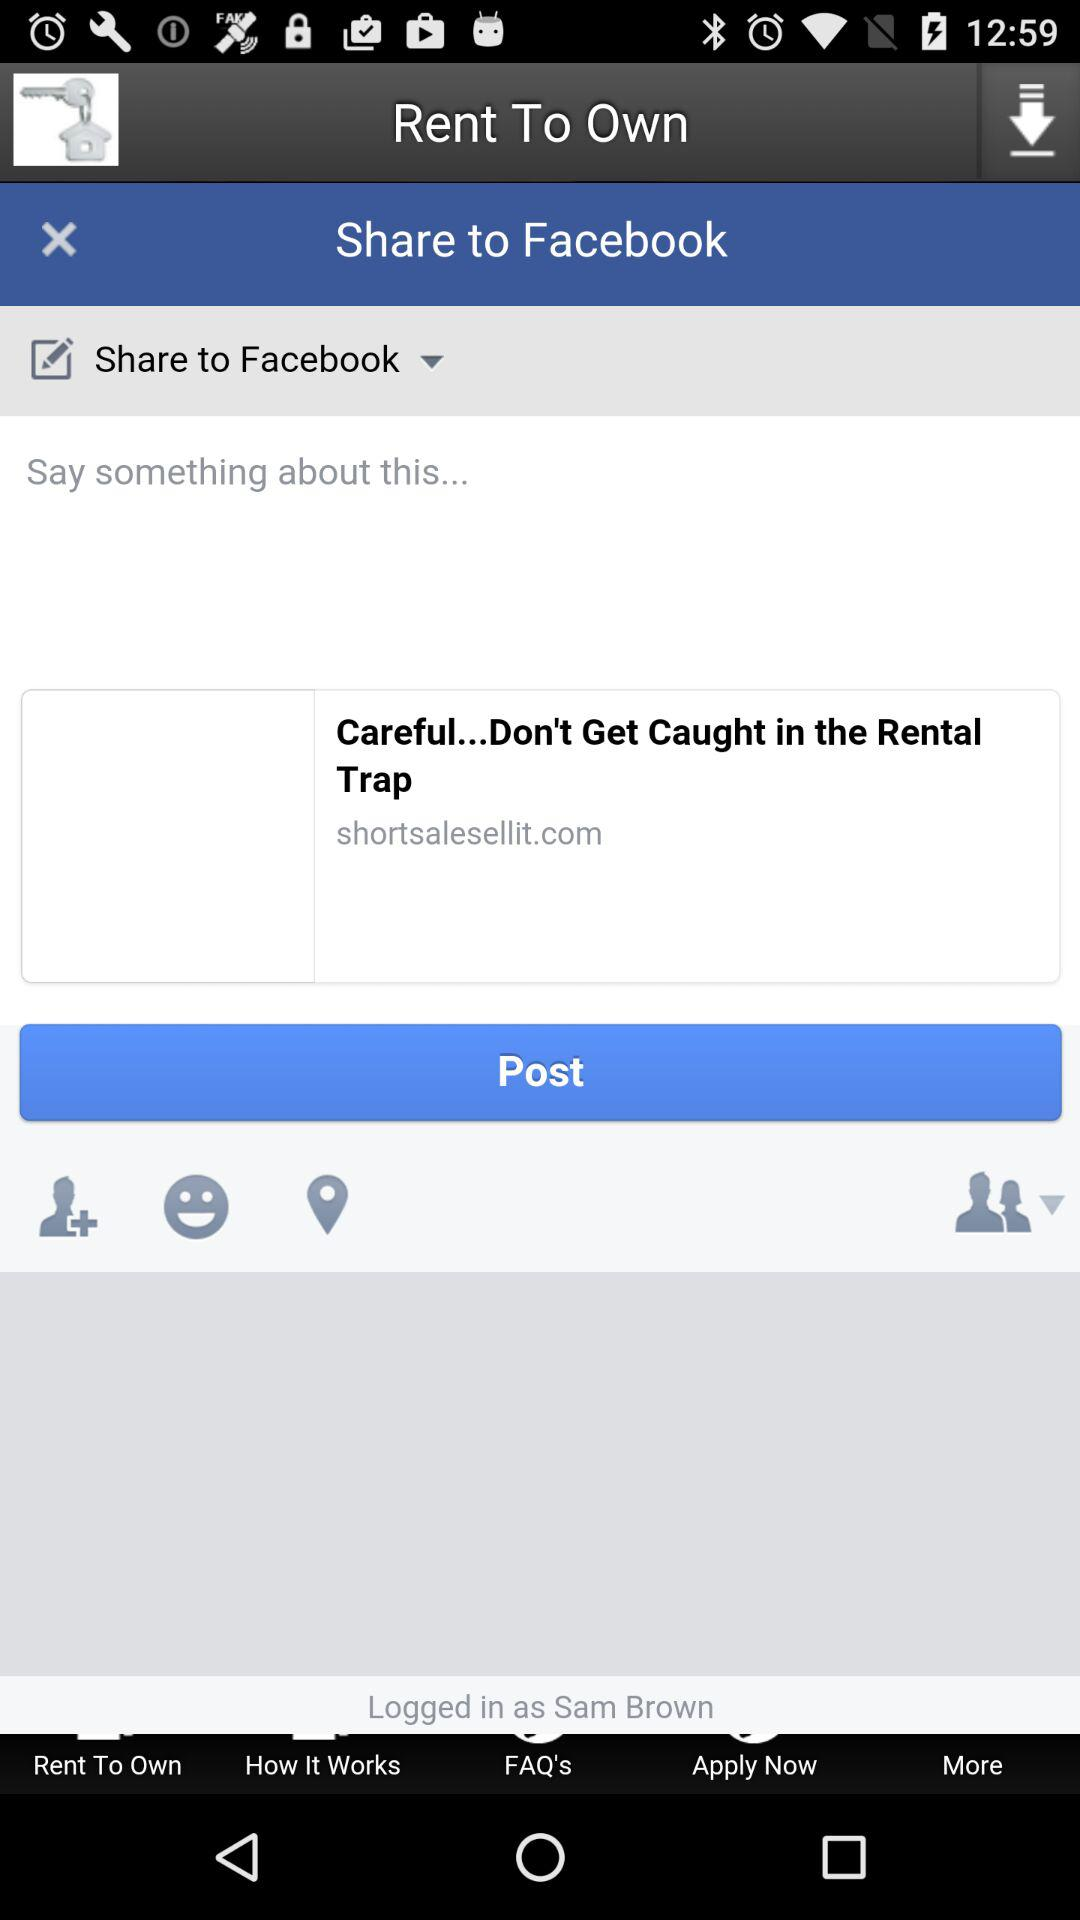What is the user name? The user name is Sam Brown. 